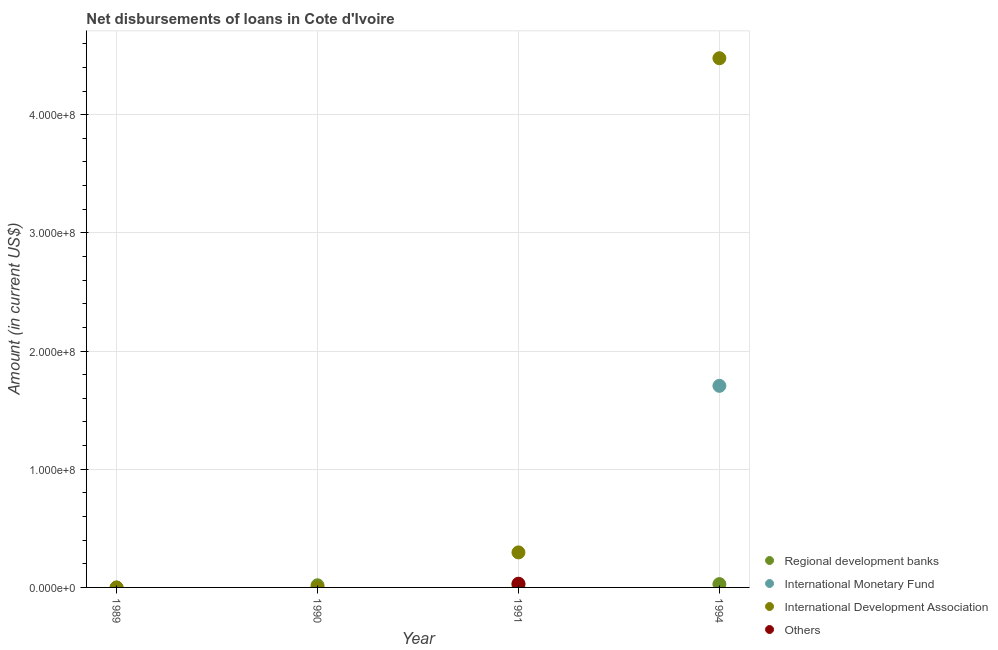What is the amount of loan disimbursed by international development association in 1990?
Provide a succinct answer. 0. Across all years, what is the maximum amount of loan disimbursed by other organisations?
Provide a short and direct response. 3.14e+06. In which year was the amount of loan disimbursed by other organisations maximum?
Give a very brief answer. 1991. What is the total amount of loan disimbursed by international monetary fund in the graph?
Your answer should be very brief. 1.71e+08. What is the difference between the amount of loan disimbursed by regional development banks in 1991 and that in 1994?
Your response must be concise. -3.19e+05. What is the difference between the amount of loan disimbursed by international monetary fund in 1989 and the amount of loan disimbursed by other organisations in 1990?
Offer a very short reply. 0. What is the average amount of loan disimbursed by international monetary fund per year?
Keep it short and to the point. 4.26e+07. In the year 1991, what is the difference between the amount of loan disimbursed by international development association and amount of loan disimbursed by regional development banks?
Your answer should be compact. 2.72e+07. In how many years, is the amount of loan disimbursed by regional development banks greater than 280000000 US$?
Offer a terse response. 0. What is the ratio of the amount of loan disimbursed by international development association in 1991 to that in 1994?
Offer a terse response. 0.07. Is the amount of loan disimbursed by international development association in 1991 less than that in 1994?
Your answer should be very brief. Yes. What is the difference between the highest and the second highest amount of loan disimbursed by regional development banks?
Your response must be concise. 3.19e+05. What is the difference between the highest and the lowest amount of loan disimbursed by regional development banks?
Provide a short and direct response. 2.80e+06. Is it the case that in every year, the sum of the amount of loan disimbursed by international monetary fund and amount of loan disimbursed by regional development banks is greater than the sum of amount of loan disimbursed by international development association and amount of loan disimbursed by other organisations?
Offer a terse response. No. Is the amount of loan disimbursed by international development association strictly greater than the amount of loan disimbursed by regional development banks over the years?
Offer a terse response. No. Is the amount of loan disimbursed by other organisations strictly less than the amount of loan disimbursed by international monetary fund over the years?
Offer a terse response. No. How many years are there in the graph?
Make the answer very short. 4. Are the values on the major ticks of Y-axis written in scientific E-notation?
Your answer should be very brief. Yes. Does the graph contain any zero values?
Make the answer very short. Yes. Where does the legend appear in the graph?
Offer a very short reply. Bottom right. What is the title of the graph?
Provide a succinct answer. Net disbursements of loans in Cote d'Ivoire. Does "Sweden" appear as one of the legend labels in the graph?
Provide a succinct answer. No. What is the Amount (in current US$) in Regional development banks in 1989?
Your answer should be compact. 0. What is the Amount (in current US$) of Regional development banks in 1990?
Your response must be concise. 1.81e+06. What is the Amount (in current US$) of International Monetary Fund in 1990?
Provide a succinct answer. 0. What is the Amount (in current US$) in Regional development banks in 1991?
Give a very brief answer. 2.48e+06. What is the Amount (in current US$) in International Development Association in 1991?
Keep it short and to the point. 2.96e+07. What is the Amount (in current US$) in Others in 1991?
Your answer should be very brief. 3.14e+06. What is the Amount (in current US$) of Regional development banks in 1994?
Provide a succinct answer. 2.80e+06. What is the Amount (in current US$) in International Monetary Fund in 1994?
Your answer should be very brief. 1.71e+08. What is the Amount (in current US$) in International Development Association in 1994?
Make the answer very short. 4.48e+08. What is the Amount (in current US$) of Others in 1994?
Offer a terse response. 0. Across all years, what is the maximum Amount (in current US$) in Regional development banks?
Provide a short and direct response. 2.80e+06. Across all years, what is the maximum Amount (in current US$) of International Monetary Fund?
Your response must be concise. 1.71e+08. Across all years, what is the maximum Amount (in current US$) in International Development Association?
Your answer should be very brief. 4.48e+08. Across all years, what is the maximum Amount (in current US$) in Others?
Make the answer very short. 3.14e+06. Across all years, what is the minimum Amount (in current US$) in International Development Association?
Your answer should be very brief. 0. What is the total Amount (in current US$) of Regional development banks in the graph?
Your answer should be very brief. 7.09e+06. What is the total Amount (in current US$) of International Monetary Fund in the graph?
Provide a succinct answer. 1.71e+08. What is the total Amount (in current US$) of International Development Association in the graph?
Make the answer very short. 4.77e+08. What is the total Amount (in current US$) of Others in the graph?
Your answer should be very brief. 3.14e+06. What is the difference between the Amount (in current US$) of Regional development banks in 1990 and that in 1991?
Your answer should be compact. -6.70e+05. What is the difference between the Amount (in current US$) of Regional development banks in 1990 and that in 1994?
Keep it short and to the point. -9.89e+05. What is the difference between the Amount (in current US$) of Regional development banks in 1991 and that in 1994?
Provide a succinct answer. -3.19e+05. What is the difference between the Amount (in current US$) in International Development Association in 1991 and that in 1994?
Keep it short and to the point. -4.18e+08. What is the difference between the Amount (in current US$) of Regional development banks in 1990 and the Amount (in current US$) of International Development Association in 1991?
Make the answer very short. -2.78e+07. What is the difference between the Amount (in current US$) of Regional development banks in 1990 and the Amount (in current US$) of Others in 1991?
Ensure brevity in your answer.  -1.33e+06. What is the difference between the Amount (in current US$) of Regional development banks in 1990 and the Amount (in current US$) of International Monetary Fund in 1994?
Offer a terse response. -1.69e+08. What is the difference between the Amount (in current US$) of Regional development banks in 1990 and the Amount (in current US$) of International Development Association in 1994?
Provide a succinct answer. -4.46e+08. What is the difference between the Amount (in current US$) in Regional development banks in 1991 and the Amount (in current US$) in International Monetary Fund in 1994?
Your answer should be compact. -1.68e+08. What is the difference between the Amount (in current US$) in Regional development banks in 1991 and the Amount (in current US$) in International Development Association in 1994?
Ensure brevity in your answer.  -4.45e+08. What is the average Amount (in current US$) in Regional development banks per year?
Offer a very short reply. 1.77e+06. What is the average Amount (in current US$) in International Monetary Fund per year?
Make the answer very short. 4.26e+07. What is the average Amount (in current US$) of International Development Association per year?
Your answer should be compact. 1.19e+08. What is the average Amount (in current US$) of Others per year?
Offer a terse response. 7.84e+05. In the year 1991, what is the difference between the Amount (in current US$) of Regional development banks and Amount (in current US$) of International Development Association?
Your response must be concise. -2.72e+07. In the year 1991, what is the difference between the Amount (in current US$) of Regional development banks and Amount (in current US$) of Others?
Give a very brief answer. -6.56e+05. In the year 1991, what is the difference between the Amount (in current US$) in International Development Association and Amount (in current US$) in Others?
Offer a terse response. 2.65e+07. In the year 1994, what is the difference between the Amount (in current US$) in Regional development banks and Amount (in current US$) in International Monetary Fund?
Give a very brief answer. -1.68e+08. In the year 1994, what is the difference between the Amount (in current US$) in Regional development banks and Amount (in current US$) in International Development Association?
Your answer should be compact. -4.45e+08. In the year 1994, what is the difference between the Amount (in current US$) of International Monetary Fund and Amount (in current US$) of International Development Association?
Your answer should be very brief. -2.77e+08. What is the ratio of the Amount (in current US$) in Regional development banks in 1990 to that in 1991?
Give a very brief answer. 0.73. What is the ratio of the Amount (in current US$) in Regional development banks in 1990 to that in 1994?
Your response must be concise. 0.65. What is the ratio of the Amount (in current US$) in Regional development banks in 1991 to that in 1994?
Make the answer very short. 0.89. What is the ratio of the Amount (in current US$) of International Development Association in 1991 to that in 1994?
Keep it short and to the point. 0.07. What is the difference between the highest and the second highest Amount (in current US$) in Regional development banks?
Your answer should be compact. 3.19e+05. What is the difference between the highest and the lowest Amount (in current US$) of Regional development banks?
Your answer should be compact. 2.80e+06. What is the difference between the highest and the lowest Amount (in current US$) in International Monetary Fund?
Your answer should be compact. 1.71e+08. What is the difference between the highest and the lowest Amount (in current US$) of International Development Association?
Give a very brief answer. 4.48e+08. What is the difference between the highest and the lowest Amount (in current US$) in Others?
Ensure brevity in your answer.  3.14e+06. 